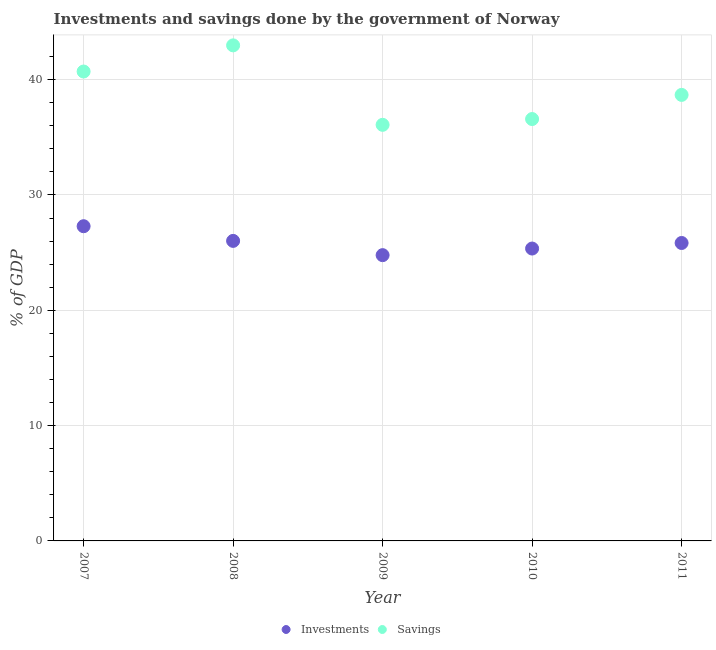What is the investments of government in 2007?
Keep it short and to the point. 27.29. Across all years, what is the maximum investments of government?
Your answer should be very brief. 27.29. Across all years, what is the minimum savings of government?
Your answer should be very brief. 36.08. In which year was the investments of government minimum?
Offer a terse response. 2009. What is the total investments of government in the graph?
Provide a short and direct response. 129.28. What is the difference between the savings of government in 2009 and that in 2010?
Provide a succinct answer. -0.5. What is the difference between the savings of government in 2010 and the investments of government in 2008?
Make the answer very short. 10.57. What is the average savings of government per year?
Provide a succinct answer. 39. In the year 2010, what is the difference between the investments of government and savings of government?
Keep it short and to the point. -11.23. In how many years, is the investments of government greater than 26 %?
Your answer should be compact. 2. What is the ratio of the investments of government in 2010 to that in 2011?
Ensure brevity in your answer.  0.98. Is the savings of government in 2007 less than that in 2010?
Give a very brief answer. No. What is the difference between the highest and the second highest investments of government?
Provide a succinct answer. 1.27. What is the difference between the highest and the lowest savings of government?
Give a very brief answer. 6.89. Is the sum of the savings of government in 2007 and 2011 greater than the maximum investments of government across all years?
Give a very brief answer. Yes. Is the savings of government strictly greater than the investments of government over the years?
Provide a short and direct response. Yes. Is the savings of government strictly less than the investments of government over the years?
Provide a short and direct response. No. How many dotlines are there?
Your answer should be very brief. 2. Does the graph contain grids?
Your answer should be compact. Yes. How are the legend labels stacked?
Provide a succinct answer. Horizontal. What is the title of the graph?
Your answer should be very brief. Investments and savings done by the government of Norway. What is the label or title of the X-axis?
Your response must be concise. Year. What is the label or title of the Y-axis?
Offer a terse response. % of GDP. What is the % of GDP in Investments in 2007?
Make the answer very short. 27.29. What is the % of GDP in Savings in 2007?
Give a very brief answer. 40.7. What is the % of GDP in Investments in 2008?
Ensure brevity in your answer.  26.02. What is the % of GDP of Savings in 2008?
Your response must be concise. 42.97. What is the % of GDP in Investments in 2009?
Offer a terse response. 24.78. What is the % of GDP of Savings in 2009?
Provide a short and direct response. 36.08. What is the % of GDP of Investments in 2010?
Keep it short and to the point. 25.35. What is the % of GDP in Savings in 2010?
Ensure brevity in your answer.  36.58. What is the % of GDP of Investments in 2011?
Your response must be concise. 25.84. What is the % of GDP of Savings in 2011?
Provide a succinct answer. 38.68. Across all years, what is the maximum % of GDP in Investments?
Provide a succinct answer. 27.29. Across all years, what is the maximum % of GDP of Savings?
Keep it short and to the point. 42.97. Across all years, what is the minimum % of GDP in Investments?
Give a very brief answer. 24.78. Across all years, what is the minimum % of GDP in Savings?
Provide a succinct answer. 36.08. What is the total % of GDP of Investments in the graph?
Offer a terse response. 129.28. What is the total % of GDP in Savings in the graph?
Provide a succinct answer. 195.02. What is the difference between the % of GDP in Investments in 2007 and that in 2008?
Offer a terse response. 1.27. What is the difference between the % of GDP of Savings in 2007 and that in 2008?
Offer a very short reply. -2.27. What is the difference between the % of GDP in Investments in 2007 and that in 2009?
Your answer should be very brief. 2.51. What is the difference between the % of GDP of Savings in 2007 and that in 2009?
Provide a short and direct response. 4.62. What is the difference between the % of GDP of Investments in 2007 and that in 2010?
Provide a short and direct response. 1.94. What is the difference between the % of GDP of Savings in 2007 and that in 2010?
Offer a very short reply. 4.12. What is the difference between the % of GDP in Investments in 2007 and that in 2011?
Your answer should be compact. 1.45. What is the difference between the % of GDP of Savings in 2007 and that in 2011?
Provide a short and direct response. 2.03. What is the difference between the % of GDP of Investments in 2008 and that in 2009?
Keep it short and to the point. 1.24. What is the difference between the % of GDP in Savings in 2008 and that in 2009?
Give a very brief answer. 6.89. What is the difference between the % of GDP of Investments in 2008 and that in 2010?
Offer a terse response. 0.66. What is the difference between the % of GDP in Savings in 2008 and that in 2010?
Provide a succinct answer. 6.39. What is the difference between the % of GDP in Investments in 2008 and that in 2011?
Provide a short and direct response. 0.18. What is the difference between the % of GDP of Savings in 2008 and that in 2011?
Give a very brief answer. 4.3. What is the difference between the % of GDP in Investments in 2009 and that in 2010?
Your response must be concise. -0.57. What is the difference between the % of GDP in Savings in 2009 and that in 2010?
Offer a very short reply. -0.5. What is the difference between the % of GDP of Investments in 2009 and that in 2011?
Your answer should be compact. -1.05. What is the difference between the % of GDP in Savings in 2009 and that in 2011?
Keep it short and to the point. -2.6. What is the difference between the % of GDP of Investments in 2010 and that in 2011?
Your answer should be very brief. -0.48. What is the difference between the % of GDP in Savings in 2010 and that in 2011?
Provide a succinct answer. -2.09. What is the difference between the % of GDP in Investments in 2007 and the % of GDP in Savings in 2008?
Ensure brevity in your answer.  -15.68. What is the difference between the % of GDP in Investments in 2007 and the % of GDP in Savings in 2009?
Your answer should be compact. -8.79. What is the difference between the % of GDP of Investments in 2007 and the % of GDP of Savings in 2010?
Your answer should be very brief. -9.29. What is the difference between the % of GDP of Investments in 2007 and the % of GDP of Savings in 2011?
Provide a succinct answer. -11.39. What is the difference between the % of GDP in Investments in 2008 and the % of GDP in Savings in 2009?
Make the answer very short. -10.06. What is the difference between the % of GDP of Investments in 2008 and the % of GDP of Savings in 2010?
Offer a terse response. -10.57. What is the difference between the % of GDP in Investments in 2008 and the % of GDP in Savings in 2011?
Your response must be concise. -12.66. What is the difference between the % of GDP in Investments in 2009 and the % of GDP in Savings in 2010?
Make the answer very short. -11.8. What is the difference between the % of GDP in Investments in 2009 and the % of GDP in Savings in 2011?
Provide a succinct answer. -13.9. What is the difference between the % of GDP in Investments in 2010 and the % of GDP in Savings in 2011?
Ensure brevity in your answer.  -13.32. What is the average % of GDP of Investments per year?
Give a very brief answer. 25.86. What is the average % of GDP of Savings per year?
Your answer should be very brief. 39. In the year 2007, what is the difference between the % of GDP in Investments and % of GDP in Savings?
Your response must be concise. -13.41. In the year 2008, what is the difference between the % of GDP of Investments and % of GDP of Savings?
Your answer should be very brief. -16.96. In the year 2009, what is the difference between the % of GDP in Investments and % of GDP in Savings?
Your answer should be very brief. -11.3. In the year 2010, what is the difference between the % of GDP in Investments and % of GDP in Savings?
Ensure brevity in your answer.  -11.23. In the year 2011, what is the difference between the % of GDP of Investments and % of GDP of Savings?
Provide a succinct answer. -12.84. What is the ratio of the % of GDP of Investments in 2007 to that in 2008?
Your answer should be compact. 1.05. What is the ratio of the % of GDP of Savings in 2007 to that in 2008?
Ensure brevity in your answer.  0.95. What is the ratio of the % of GDP of Investments in 2007 to that in 2009?
Your answer should be very brief. 1.1. What is the ratio of the % of GDP in Savings in 2007 to that in 2009?
Your answer should be very brief. 1.13. What is the ratio of the % of GDP of Investments in 2007 to that in 2010?
Your answer should be compact. 1.08. What is the ratio of the % of GDP of Savings in 2007 to that in 2010?
Your response must be concise. 1.11. What is the ratio of the % of GDP in Investments in 2007 to that in 2011?
Offer a terse response. 1.06. What is the ratio of the % of GDP of Savings in 2007 to that in 2011?
Provide a short and direct response. 1.05. What is the ratio of the % of GDP of Investments in 2008 to that in 2009?
Your answer should be compact. 1.05. What is the ratio of the % of GDP of Savings in 2008 to that in 2009?
Your answer should be very brief. 1.19. What is the ratio of the % of GDP in Investments in 2008 to that in 2010?
Your response must be concise. 1.03. What is the ratio of the % of GDP of Savings in 2008 to that in 2010?
Give a very brief answer. 1.17. What is the ratio of the % of GDP in Investments in 2008 to that in 2011?
Keep it short and to the point. 1.01. What is the ratio of the % of GDP of Investments in 2009 to that in 2010?
Your response must be concise. 0.98. What is the ratio of the % of GDP of Savings in 2009 to that in 2010?
Your answer should be compact. 0.99. What is the ratio of the % of GDP of Investments in 2009 to that in 2011?
Provide a succinct answer. 0.96. What is the ratio of the % of GDP of Savings in 2009 to that in 2011?
Keep it short and to the point. 0.93. What is the ratio of the % of GDP of Investments in 2010 to that in 2011?
Your answer should be very brief. 0.98. What is the ratio of the % of GDP of Savings in 2010 to that in 2011?
Keep it short and to the point. 0.95. What is the difference between the highest and the second highest % of GDP in Investments?
Provide a short and direct response. 1.27. What is the difference between the highest and the second highest % of GDP of Savings?
Your answer should be compact. 2.27. What is the difference between the highest and the lowest % of GDP in Investments?
Ensure brevity in your answer.  2.51. What is the difference between the highest and the lowest % of GDP in Savings?
Provide a short and direct response. 6.89. 